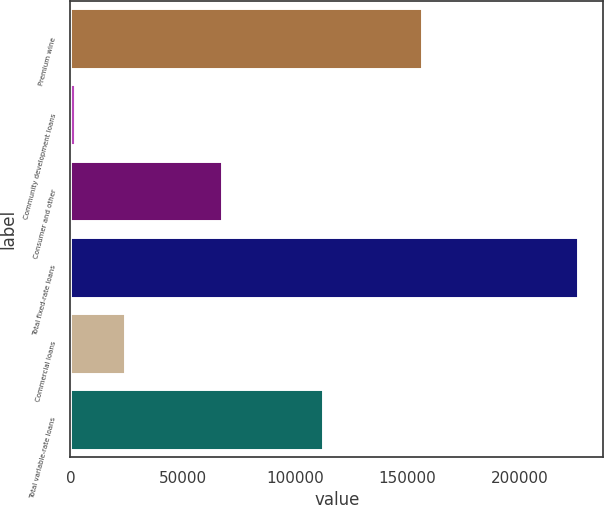<chart> <loc_0><loc_0><loc_500><loc_500><bar_chart><fcel>Premium wine<fcel>Community development loans<fcel>Consumer and other<fcel>Total fixed-rate loans<fcel>Commercial loans<fcel>Total variable-rate loans<nl><fcel>156550<fcel>1901<fcel>67542<fcel>225993<fcel>24310.2<fcel>112297<nl></chart> 